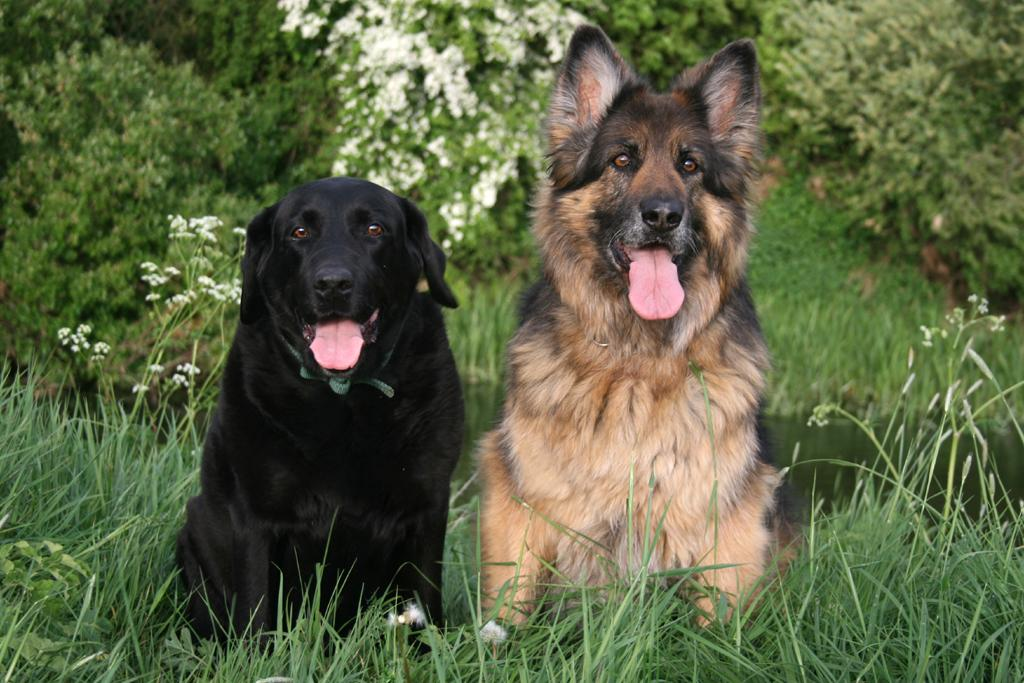How many dogs are in the image? There are two dogs sitting on the grass. What is the background of the image? There is water visible behind the dogs. What type of vegetation can be seen at the top of the image? There are plants with flowers at the top of the image. What other natural elements are present in the image? There are trees on the grassland. What type of crime is being committed in the image? There is no crime being committed in the image; it features two dogs sitting on the grass. How does the image depict the concept of adjustment? The image does not depict the concept of adjustment; it simply shows two dogs sitting on the grass with a background of water and trees. 